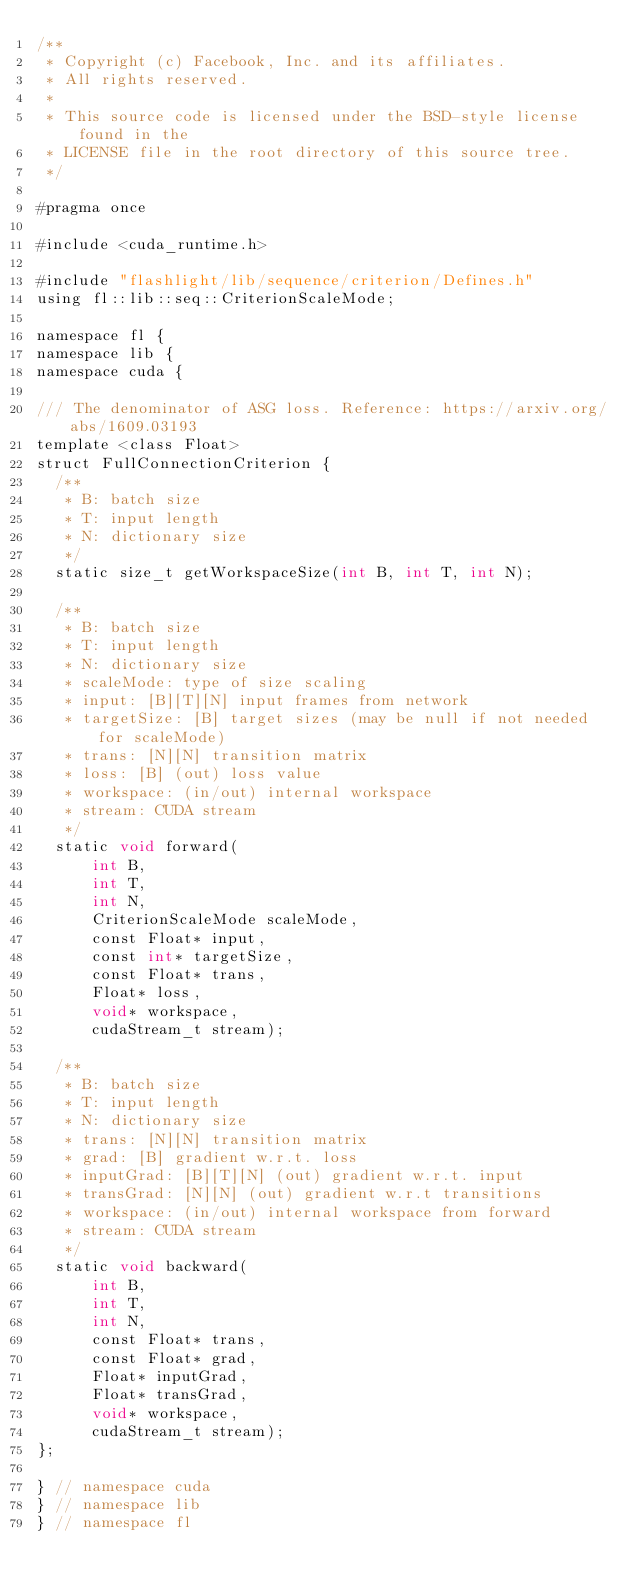<code> <loc_0><loc_0><loc_500><loc_500><_Cuda_>/**
 * Copyright (c) Facebook, Inc. and its affiliates.
 * All rights reserved.
 *
 * This source code is licensed under the BSD-style license found in the
 * LICENSE file in the root directory of this source tree.
 */

#pragma once

#include <cuda_runtime.h>

#include "flashlight/lib/sequence/criterion/Defines.h"
using fl::lib::seq::CriterionScaleMode;

namespace fl {
namespace lib {
namespace cuda {

/// The denominator of ASG loss. Reference: https://arxiv.org/abs/1609.03193
template <class Float>
struct FullConnectionCriterion {
  /**
   * B: batch size
   * T: input length
   * N: dictionary size
   */
  static size_t getWorkspaceSize(int B, int T, int N);

  /**
   * B: batch size
   * T: input length
   * N: dictionary size
   * scaleMode: type of size scaling
   * input: [B][T][N] input frames from network
   * targetSize: [B] target sizes (may be null if not needed for scaleMode)
   * trans: [N][N] transition matrix
   * loss: [B] (out) loss value
   * workspace: (in/out) internal workspace
   * stream: CUDA stream
   */
  static void forward(
      int B,
      int T,
      int N,
      CriterionScaleMode scaleMode,
      const Float* input,
      const int* targetSize,
      const Float* trans,
      Float* loss,
      void* workspace,
      cudaStream_t stream);

  /**
   * B: batch size
   * T: input length
   * N: dictionary size
   * trans: [N][N] transition matrix
   * grad: [B] gradient w.r.t. loss
   * inputGrad: [B][T][N] (out) gradient w.r.t. input
   * transGrad: [N][N] (out) gradient w.r.t transitions
   * workspace: (in/out) internal workspace from forward
   * stream: CUDA stream
   */
  static void backward(
      int B,
      int T,
      int N,
      const Float* trans,
      const Float* grad,
      Float* inputGrad,
      Float* transGrad,
      void* workspace,
      cudaStream_t stream);
};

} // namespace cuda
} // namespace lib
} // namespace fl
</code> 